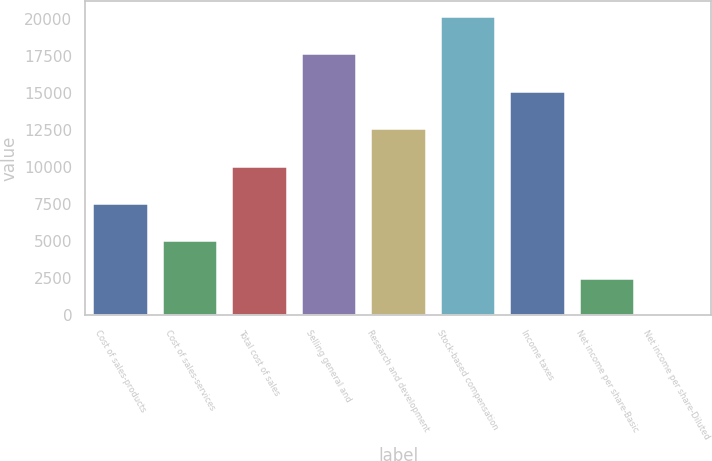Convert chart. <chart><loc_0><loc_0><loc_500><loc_500><bar_chart><fcel>Cost of sales-products<fcel>Cost of sales-services<fcel>Total cost of sales<fcel>Selling general and<fcel>Research and development<fcel>Stock-based compensation<fcel>Income taxes<fcel>Net income per share-Basic<fcel>Net income per share-Diluted<nl><fcel>7578.31<fcel>5052.35<fcel>10104.3<fcel>17682.2<fcel>12630.2<fcel>20208.1<fcel>15156.2<fcel>2526.39<fcel>0.43<nl></chart> 